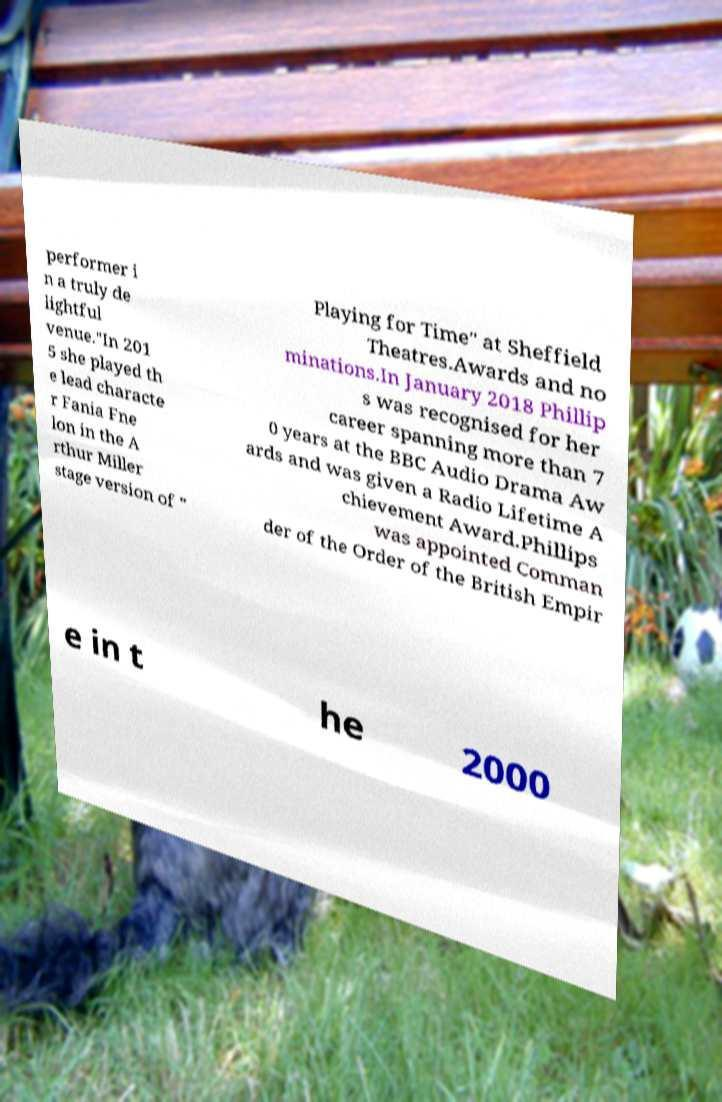Could you assist in decoding the text presented in this image and type it out clearly? performer i n a truly de lightful venue."In 201 5 she played th e lead characte r Fania Fne lon in the A rthur Miller stage version of " Playing for Time" at Sheffield Theatres.Awards and no minations.In January 2018 Phillip s was recognised for her career spanning more than 7 0 years at the BBC Audio Drama Aw ards and was given a Radio Lifetime A chievement Award.Phillips was appointed Comman der of the Order of the British Empir e in t he 2000 